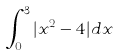Convert formula to latex. <formula><loc_0><loc_0><loc_500><loc_500>\int _ { 0 } ^ { 3 } | x ^ { 2 } - 4 | d x</formula> 